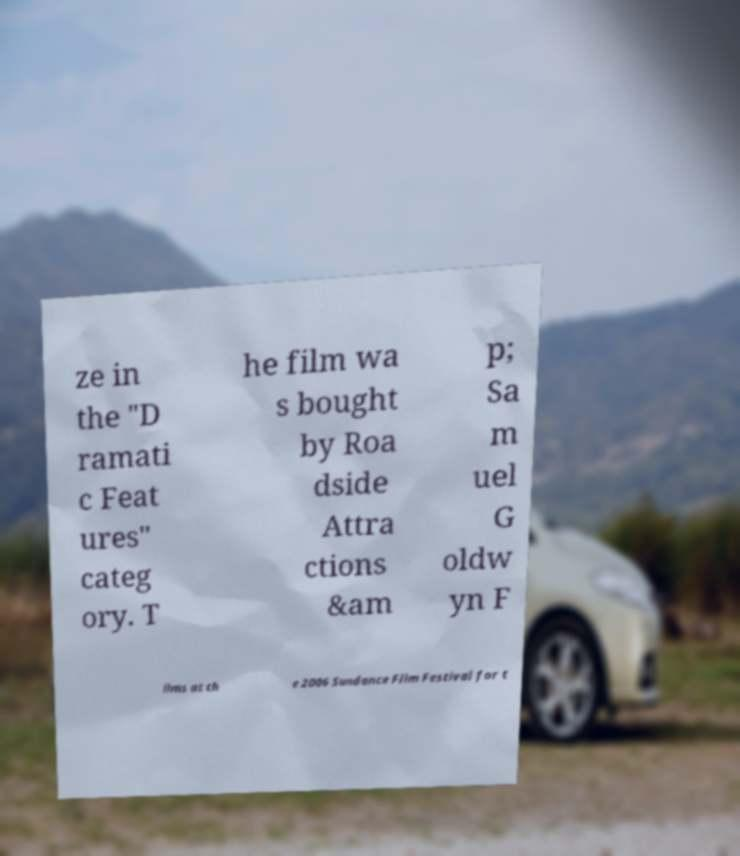I need the written content from this picture converted into text. Can you do that? ze in the "D ramati c Feat ures" categ ory. T he film wa s bought by Roa dside Attra ctions &am p; Sa m uel G oldw yn F ilms at th e 2006 Sundance Film Festival for t 